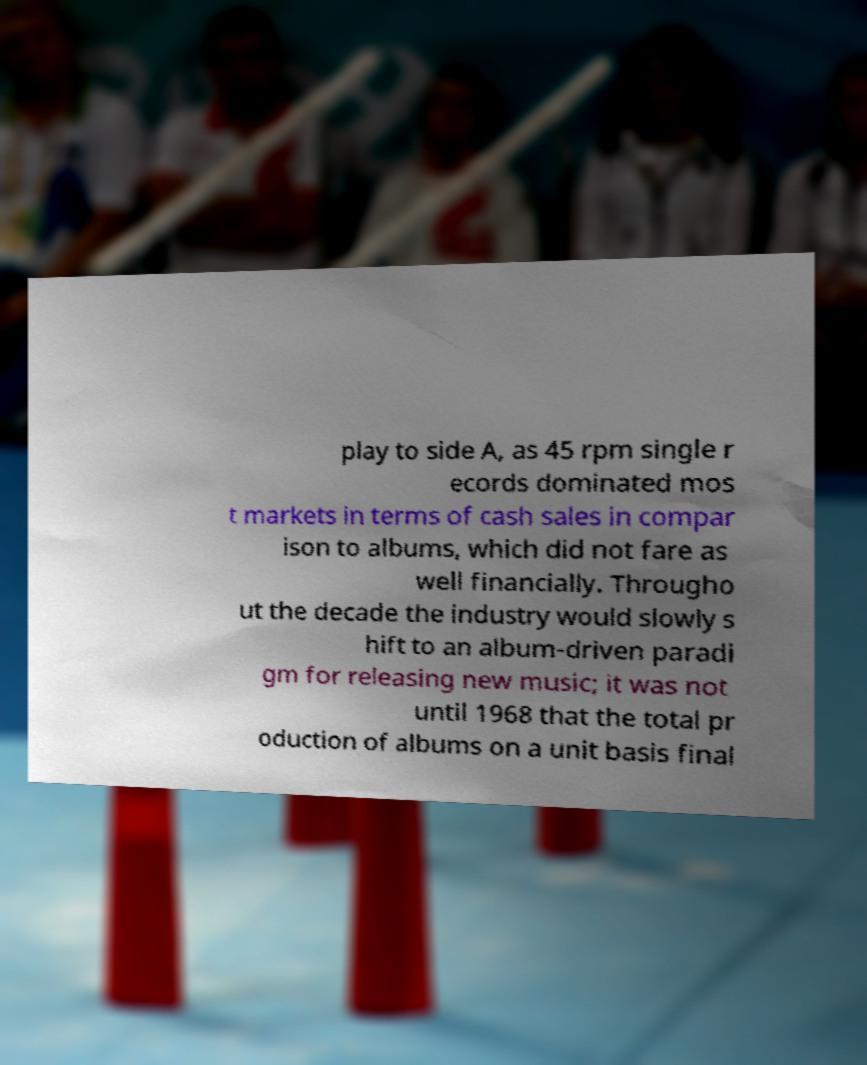Please identify and transcribe the text found in this image. play to side A, as 45 rpm single r ecords dominated mos t markets in terms of cash sales in compar ison to albums, which did not fare as well financially. Througho ut the decade the industry would slowly s hift to an album-driven paradi gm for releasing new music; it was not until 1968 that the total pr oduction of albums on a unit basis final 